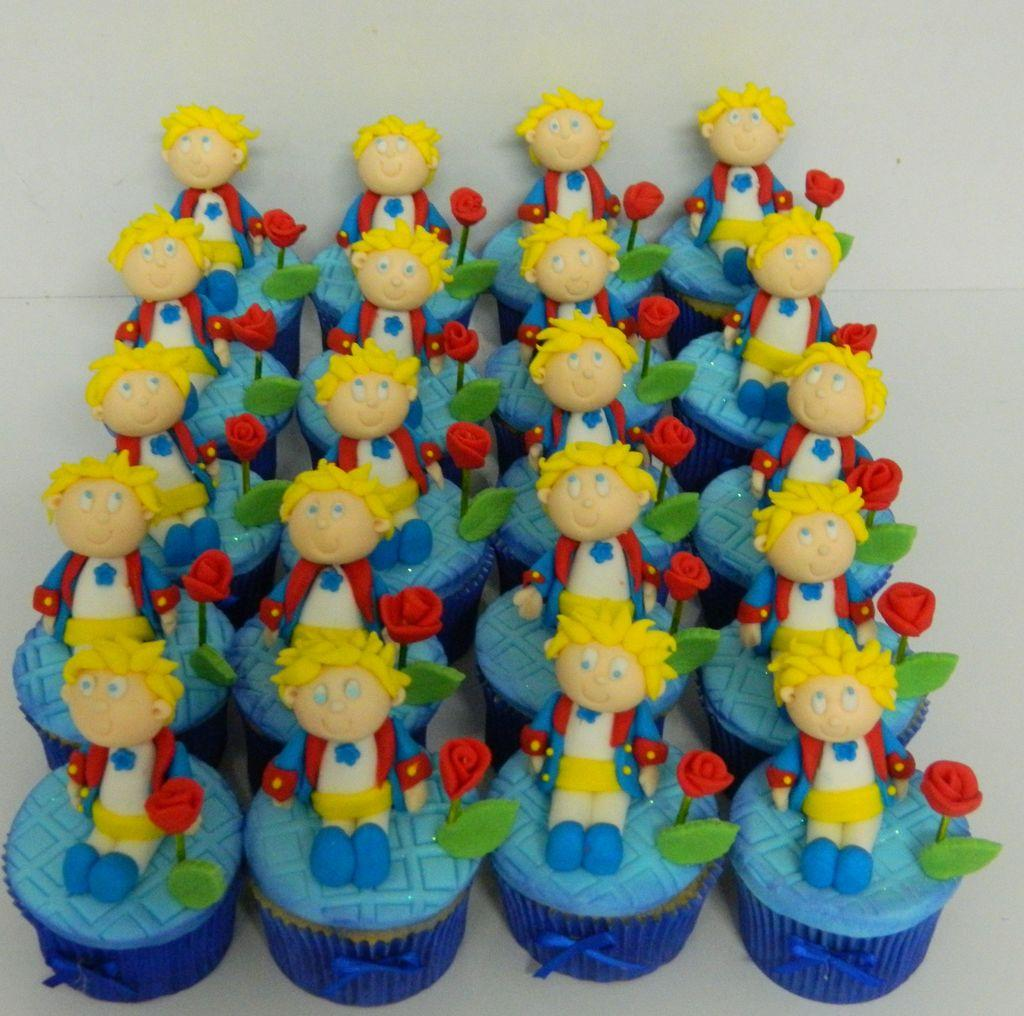What type of objects can be seen in the image? There are toys in the image. What colors are the toys? The toys are in blue and red colors. On what surface are the toys placed? The toys are placed on a white surface. What can be seen in the background of the image? There is a wall in the background of the image. What page of the book is the toy dog reading in the image? There is no book or toy dog present in the image. Can you see any branches in the image? There are no branches visible in the image. 